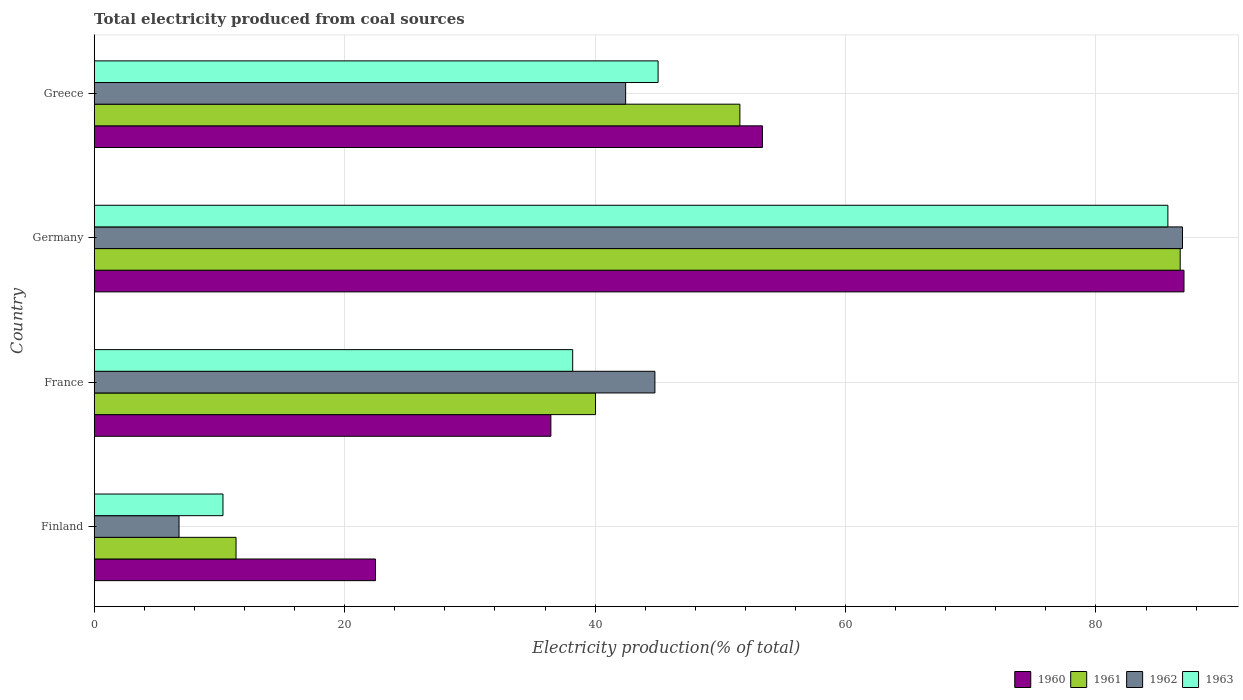How many groups of bars are there?
Make the answer very short. 4. Are the number of bars on each tick of the Y-axis equal?
Provide a succinct answer. Yes. How many bars are there on the 3rd tick from the bottom?
Provide a short and direct response. 4. In how many cases, is the number of bars for a given country not equal to the number of legend labels?
Your answer should be very brief. 0. What is the total electricity produced in 1960 in Finland?
Offer a terse response. 22.46. Across all countries, what is the maximum total electricity produced in 1963?
Your response must be concise. 85.74. Across all countries, what is the minimum total electricity produced in 1962?
Offer a terse response. 6.78. What is the total total electricity produced in 1961 in the graph?
Make the answer very short. 189.65. What is the difference between the total electricity produced in 1963 in Finland and that in Greece?
Keep it short and to the point. -34.75. What is the difference between the total electricity produced in 1962 in France and the total electricity produced in 1961 in Germany?
Make the answer very short. -41.95. What is the average total electricity produced in 1963 per country?
Offer a very short reply. 44.82. What is the difference between the total electricity produced in 1961 and total electricity produced in 1960 in Greece?
Your response must be concise. -1.8. What is the ratio of the total electricity produced in 1963 in Finland to that in France?
Ensure brevity in your answer.  0.27. Is the difference between the total electricity produced in 1961 in Germany and Greece greater than the difference between the total electricity produced in 1960 in Germany and Greece?
Your answer should be very brief. Yes. What is the difference between the highest and the second highest total electricity produced in 1961?
Your answer should be very brief. 35.16. What is the difference between the highest and the lowest total electricity produced in 1963?
Provide a short and direct response. 75.46. Is the sum of the total electricity produced in 1962 in Finland and France greater than the maximum total electricity produced in 1961 across all countries?
Offer a very short reply. No. Is it the case that in every country, the sum of the total electricity produced in 1962 and total electricity produced in 1963 is greater than the sum of total electricity produced in 1960 and total electricity produced in 1961?
Give a very brief answer. No. How many bars are there?
Your answer should be very brief. 16. What is the difference between two consecutive major ticks on the X-axis?
Give a very brief answer. 20. Are the values on the major ticks of X-axis written in scientific E-notation?
Give a very brief answer. No. Does the graph contain grids?
Offer a terse response. Yes. How are the legend labels stacked?
Offer a very short reply. Horizontal. What is the title of the graph?
Your response must be concise. Total electricity produced from coal sources. Does "1988" appear as one of the legend labels in the graph?
Provide a succinct answer. No. What is the Electricity production(% of total) in 1960 in Finland?
Provide a succinct answer. 22.46. What is the Electricity production(% of total) in 1961 in Finland?
Keep it short and to the point. 11.33. What is the Electricity production(% of total) of 1962 in Finland?
Offer a very short reply. 6.78. What is the Electricity production(% of total) in 1963 in Finland?
Your answer should be very brief. 10.28. What is the Electricity production(% of total) of 1960 in France?
Provide a short and direct response. 36.47. What is the Electricity production(% of total) in 1961 in France?
Your answer should be compact. 40.03. What is the Electricity production(% of total) in 1962 in France?
Give a very brief answer. 44.78. What is the Electricity production(% of total) of 1963 in France?
Provide a short and direct response. 38.21. What is the Electricity production(% of total) of 1960 in Germany?
Provide a short and direct response. 87.03. What is the Electricity production(% of total) in 1961 in Germany?
Keep it short and to the point. 86.73. What is the Electricity production(% of total) of 1962 in Germany?
Your answer should be very brief. 86.91. What is the Electricity production(% of total) of 1963 in Germany?
Provide a succinct answer. 85.74. What is the Electricity production(% of total) of 1960 in Greece?
Your answer should be compact. 53.36. What is the Electricity production(% of total) of 1961 in Greece?
Offer a very short reply. 51.56. What is the Electricity production(% of total) in 1962 in Greece?
Offer a very short reply. 42.44. What is the Electricity production(% of total) in 1963 in Greece?
Your answer should be very brief. 45.03. Across all countries, what is the maximum Electricity production(% of total) in 1960?
Offer a terse response. 87.03. Across all countries, what is the maximum Electricity production(% of total) in 1961?
Offer a very short reply. 86.73. Across all countries, what is the maximum Electricity production(% of total) in 1962?
Provide a short and direct response. 86.91. Across all countries, what is the maximum Electricity production(% of total) in 1963?
Your answer should be very brief. 85.74. Across all countries, what is the minimum Electricity production(% of total) of 1960?
Keep it short and to the point. 22.46. Across all countries, what is the minimum Electricity production(% of total) of 1961?
Offer a very short reply. 11.33. Across all countries, what is the minimum Electricity production(% of total) in 1962?
Your response must be concise. 6.78. Across all countries, what is the minimum Electricity production(% of total) in 1963?
Your response must be concise. 10.28. What is the total Electricity production(% of total) in 1960 in the graph?
Provide a short and direct response. 199.32. What is the total Electricity production(% of total) of 1961 in the graph?
Keep it short and to the point. 189.65. What is the total Electricity production(% of total) of 1962 in the graph?
Your answer should be very brief. 180.9. What is the total Electricity production(% of total) in 1963 in the graph?
Make the answer very short. 179.27. What is the difference between the Electricity production(% of total) of 1960 in Finland and that in France?
Offer a very short reply. -14.01. What is the difference between the Electricity production(% of total) in 1961 in Finland and that in France?
Make the answer very short. -28.71. What is the difference between the Electricity production(% of total) of 1962 in Finland and that in France?
Your answer should be compact. -38. What is the difference between the Electricity production(% of total) in 1963 in Finland and that in France?
Ensure brevity in your answer.  -27.93. What is the difference between the Electricity production(% of total) in 1960 in Finland and that in Germany?
Your answer should be compact. -64.57. What is the difference between the Electricity production(% of total) in 1961 in Finland and that in Germany?
Your response must be concise. -75.4. What is the difference between the Electricity production(% of total) in 1962 in Finland and that in Germany?
Ensure brevity in your answer.  -80.13. What is the difference between the Electricity production(% of total) in 1963 in Finland and that in Germany?
Ensure brevity in your answer.  -75.46. What is the difference between the Electricity production(% of total) of 1960 in Finland and that in Greece?
Your answer should be very brief. -30.9. What is the difference between the Electricity production(% of total) in 1961 in Finland and that in Greece?
Your response must be concise. -40.24. What is the difference between the Electricity production(% of total) in 1962 in Finland and that in Greece?
Your answer should be very brief. -35.66. What is the difference between the Electricity production(% of total) of 1963 in Finland and that in Greece?
Your answer should be very brief. -34.75. What is the difference between the Electricity production(% of total) in 1960 in France and that in Germany?
Keep it short and to the point. -50.56. What is the difference between the Electricity production(% of total) of 1961 in France and that in Germany?
Keep it short and to the point. -46.69. What is the difference between the Electricity production(% of total) in 1962 in France and that in Germany?
Your response must be concise. -42.13. What is the difference between the Electricity production(% of total) in 1963 in France and that in Germany?
Offer a terse response. -47.53. What is the difference between the Electricity production(% of total) in 1960 in France and that in Greece?
Keep it short and to the point. -16.89. What is the difference between the Electricity production(% of total) of 1961 in France and that in Greece?
Give a very brief answer. -11.53. What is the difference between the Electricity production(% of total) of 1962 in France and that in Greece?
Provide a short and direct response. 2.34. What is the difference between the Electricity production(% of total) of 1963 in France and that in Greece?
Ensure brevity in your answer.  -6.82. What is the difference between the Electricity production(% of total) in 1960 in Germany and that in Greece?
Your answer should be very brief. 33.67. What is the difference between the Electricity production(% of total) of 1961 in Germany and that in Greece?
Your response must be concise. 35.16. What is the difference between the Electricity production(% of total) in 1962 in Germany and that in Greece?
Ensure brevity in your answer.  44.47. What is the difference between the Electricity production(% of total) in 1963 in Germany and that in Greece?
Offer a terse response. 40.71. What is the difference between the Electricity production(% of total) of 1960 in Finland and the Electricity production(% of total) of 1961 in France?
Your answer should be very brief. -17.57. What is the difference between the Electricity production(% of total) in 1960 in Finland and the Electricity production(% of total) in 1962 in France?
Provide a short and direct response. -22.31. What is the difference between the Electricity production(% of total) of 1960 in Finland and the Electricity production(% of total) of 1963 in France?
Ensure brevity in your answer.  -15.75. What is the difference between the Electricity production(% of total) in 1961 in Finland and the Electricity production(% of total) in 1962 in France?
Offer a very short reply. -33.45. What is the difference between the Electricity production(% of total) in 1961 in Finland and the Electricity production(% of total) in 1963 in France?
Provide a short and direct response. -26.88. What is the difference between the Electricity production(% of total) of 1962 in Finland and the Electricity production(% of total) of 1963 in France?
Keep it short and to the point. -31.44. What is the difference between the Electricity production(% of total) of 1960 in Finland and the Electricity production(% of total) of 1961 in Germany?
Your answer should be very brief. -64.26. What is the difference between the Electricity production(% of total) of 1960 in Finland and the Electricity production(% of total) of 1962 in Germany?
Your answer should be compact. -64.45. What is the difference between the Electricity production(% of total) of 1960 in Finland and the Electricity production(% of total) of 1963 in Germany?
Give a very brief answer. -63.28. What is the difference between the Electricity production(% of total) in 1961 in Finland and the Electricity production(% of total) in 1962 in Germany?
Your answer should be very brief. -75.58. What is the difference between the Electricity production(% of total) in 1961 in Finland and the Electricity production(% of total) in 1963 in Germany?
Your answer should be compact. -74.41. What is the difference between the Electricity production(% of total) of 1962 in Finland and the Electricity production(% of total) of 1963 in Germany?
Provide a short and direct response. -78.97. What is the difference between the Electricity production(% of total) in 1960 in Finland and the Electricity production(% of total) in 1961 in Greece?
Provide a short and direct response. -29.1. What is the difference between the Electricity production(% of total) in 1960 in Finland and the Electricity production(% of total) in 1962 in Greece?
Provide a short and direct response. -19.98. What is the difference between the Electricity production(% of total) of 1960 in Finland and the Electricity production(% of total) of 1963 in Greece?
Offer a terse response. -22.57. What is the difference between the Electricity production(% of total) in 1961 in Finland and the Electricity production(% of total) in 1962 in Greece?
Offer a terse response. -31.11. What is the difference between the Electricity production(% of total) of 1961 in Finland and the Electricity production(% of total) of 1963 in Greece?
Keep it short and to the point. -33.7. What is the difference between the Electricity production(% of total) of 1962 in Finland and the Electricity production(% of total) of 1963 in Greece?
Ensure brevity in your answer.  -38.26. What is the difference between the Electricity production(% of total) of 1960 in France and the Electricity production(% of total) of 1961 in Germany?
Your response must be concise. -50.26. What is the difference between the Electricity production(% of total) in 1960 in France and the Electricity production(% of total) in 1962 in Germany?
Give a very brief answer. -50.44. What is the difference between the Electricity production(% of total) in 1960 in France and the Electricity production(% of total) in 1963 in Germany?
Your answer should be compact. -49.27. What is the difference between the Electricity production(% of total) in 1961 in France and the Electricity production(% of total) in 1962 in Germany?
Ensure brevity in your answer.  -46.87. What is the difference between the Electricity production(% of total) in 1961 in France and the Electricity production(% of total) in 1963 in Germany?
Offer a very short reply. -45.71. What is the difference between the Electricity production(% of total) in 1962 in France and the Electricity production(% of total) in 1963 in Germany?
Your answer should be compact. -40.97. What is the difference between the Electricity production(% of total) of 1960 in France and the Electricity production(% of total) of 1961 in Greece?
Offer a terse response. -15.09. What is the difference between the Electricity production(% of total) of 1960 in France and the Electricity production(% of total) of 1962 in Greece?
Provide a short and direct response. -5.97. What is the difference between the Electricity production(% of total) of 1960 in France and the Electricity production(% of total) of 1963 in Greece?
Provide a short and direct response. -8.56. What is the difference between the Electricity production(% of total) of 1961 in France and the Electricity production(% of total) of 1962 in Greece?
Your answer should be very brief. -2.41. What is the difference between the Electricity production(% of total) in 1961 in France and the Electricity production(% of total) in 1963 in Greece?
Ensure brevity in your answer.  -5. What is the difference between the Electricity production(% of total) in 1962 in France and the Electricity production(% of total) in 1963 in Greece?
Offer a very short reply. -0.25. What is the difference between the Electricity production(% of total) of 1960 in Germany and the Electricity production(% of total) of 1961 in Greece?
Provide a succinct answer. 35.47. What is the difference between the Electricity production(% of total) in 1960 in Germany and the Electricity production(% of total) in 1962 in Greece?
Give a very brief answer. 44.59. What is the difference between the Electricity production(% of total) in 1960 in Germany and the Electricity production(% of total) in 1963 in Greece?
Ensure brevity in your answer.  42. What is the difference between the Electricity production(% of total) of 1961 in Germany and the Electricity production(% of total) of 1962 in Greece?
Offer a terse response. 44.29. What is the difference between the Electricity production(% of total) in 1961 in Germany and the Electricity production(% of total) in 1963 in Greece?
Offer a very short reply. 41.69. What is the difference between the Electricity production(% of total) in 1962 in Germany and the Electricity production(% of total) in 1963 in Greece?
Your answer should be compact. 41.88. What is the average Electricity production(% of total) in 1960 per country?
Give a very brief answer. 49.83. What is the average Electricity production(% of total) of 1961 per country?
Your response must be concise. 47.41. What is the average Electricity production(% of total) in 1962 per country?
Your response must be concise. 45.23. What is the average Electricity production(% of total) in 1963 per country?
Your answer should be compact. 44.82. What is the difference between the Electricity production(% of total) of 1960 and Electricity production(% of total) of 1961 in Finland?
Your answer should be compact. 11.14. What is the difference between the Electricity production(% of total) in 1960 and Electricity production(% of total) in 1962 in Finland?
Offer a terse response. 15.69. What is the difference between the Electricity production(% of total) of 1960 and Electricity production(% of total) of 1963 in Finland?
Keep it short and to the point. 12.18. What is the difference between the Electricity production(% of total) of 1961 and Electricity production(% of total) of 1962 in Finland?
Keep it short and to the point. 4.55. What is the difference between the Electricity production(% of total) in 1961 and Electricity production(% of total) in 1963 in Finland?
Offer a very short reply. 1.04. What is the difference between the Electricity production(% of total) in 1962 and Electricity production(% of total) in 1963 in Finland?
Keep it short and to the point. -3.51. What is the difference between the Electricity production(% of total) in 1960 and Electricity production(% of total) in 1961 in France?
Your response must be concise. -3.57. What is the difference between the Electricity production(% of total) of 1960 and Electricity production(% of total) of 1962 in France?
Keep it short and to the point. -8.31. What is the difference between the Electricity production(% of total) in 1960 and Electricity production(% of total) in 1963 in France?
Keep it short and to the point. -1.74. What is the difference between the Electricity production(% of total) of 1961 and Electricity production(% of total) of 1962 in France?
Make the answer very short. -4.74. What is the difference between the Electricity production(% of total) in 1961 and Electricity production(% of total) in 1963 in France?
Keep it short and to the point. 1.82. What is the difference between the Electricity production(% of total) of 1962 and Electricity production(% of total) of 1963 in France?
Your answer should be very brief. 6.57. What is the difference between the Electricity production(% of total) in 1960 and Electricity production(% of total) in 1961 in Germany?
Offer a very short reply. 0.3. What is the difference between the Electricity production(% of total) of 1960 and Electricity production(% of total) of 1962 in Germany?
Keep it short and to the point. 0.12. What is the difference between the Electricity production(% of total) of 1960 and Electricity production(% of total) of 1963 in Germany?
Make the answer very short. 1.29. What is the difference between the Electricity production(% of total) in 1961 and Electricity production(% of total) in 1962 in Germany?
Offer a very short reply. -0.18. What is the difference between the Electricity production(% of total) of 1961 and Electricity production(% of total) of 1963 in Germany?
Your answer should be compact. 0.98. What is the difference between the Electricity production(% of total) in 1960 and Electricity production(% of total) in 1961 in Greece?
Your answer should be compact. 1.8. What is the difference between the Electricity production(% of total) of 1960 and Electricity production(% of total) of 1962 in Greece?
Keep it short and to the point. 10.92. What is the difference between the Electricity production(% of total) in 1960 and Electricity production(% of total) in 1963 in Greece?
Make the answer very short. 8.33. What is the difference between the Electricity production(% of total) of 1961 and Electricity production(% of total) of 1962 in Greece?
Make the answer very short. 9.12. What is the difference between the Electricity production(% of total) in 1961 and Electricity production(% of total) in 1963 in Greece?
Ensure brevity in your answer.  6.53. What is the difference between the Electricity production(% of total) of 1962 and Electricity production(% of total) of 1963 in Greece?
Keep it short and to the point. -2.59. What is the ratio of the Electricity production(% of total) in 1960 in Finland to that in France?
Your answer should be compact. 0.62. What is the ratio of the Electricity production(% of total) of 1961 in Finland to that in France?
Ensure brevity in your answer.  0.28. What is the ratio of the Electricity production(% of total) of 1962 in Finland to that in France?
Provide a succinct answer. 0.15. What is the ratio of the Electricity production(% of total) in 1963 in Finland to that in France?
Your answer should be compact. 0.27. What is the ratio of the Electricity production(% of total) in 1960 in Finland to that in Germany?
Your answer should be very brief. 0.26. What is the ratio of the Electricity production(% of total) of 1961 in Finland to that in Germany?
Your answer should be very brief. 0.13. What is the ratio of the Electricity production(% of total) in 1962 in Finland to that in Germany?
Your answer should be very brief. 0.08. What is the ratio of the Electricity production(% of total) in 1963 in Finland to that in Germany?
Your response must be concise. 0.12. What is the ratio of the Electricity production(% of total) of 1960 in Finland to that in Greece?
Offer a terse response. 0.42. What is the ratio of the Electricity production(% of total) of 1961 in Finland to that in Greece?
Ensure brevity in your answer.  0.22. What is the ratio of the Electricity production(% of total) in 1962 in Finland to that in Greece?
Provide a succinct answer. 0.16. What is the ratio of the Electricity production(% of total) of 1963 in Finland to that in Greece?
Offer a very short reply. 0.23. What is the ratio of the Electricity production(% of total) of 1960 in France to that in Germany?
Provide a short and direct response. 0.42. What is the ratio of the Electricity production(% of total) of 1961 in France to that in Germany?
Offer a terse response. 0.46. What is the ratio of the Electricity production(% of total) of 1962 in France to that in Germany?
Provide a short and direct response. 0.52. What is the ratio of the Electricity production(% of total) of 1963 in France to that in Germany?
Offer a very short reply. 0.45. What is the ratio of the Electricity production(% of total) in 1960 in France to that in Greece?
Provide a short and direct response. 0.68. What is the ratio of the Electricity production(% of total) of 1961 in France to that in Greece?
Make the answer very short. 0.78. What is the ratio of the Electricity production(% of total) in 1962 in France to that in Greece?
Keep it short and to the point. 1.06. What is the ratio of the Electricity production(% of total) of 1963 in France to that in Greece?
Provide a succinct answer. 0.85. What is the ratio of the Electricity production(% of total) in 1960 in Germany to that in Greece?
Keep it short and to the point. 1.63. What is the ratio of the Electricity production(% of total) in 1961 in Germany to that in Greece?
Your response must be concise. 1.68. What is the ratio of the Electricity production(% of total) in 1962 in Germany to that in Greece?
Make the answer very short. 2.05. What is the ratio of the Electricity production(% of total) in 1963 in Germany to that in Greece?
Offer a terse response. 1.9. What is the difference between the highest and the second highest Electricity production(% of total) in 1960?
Offer a very short reply. 33.67. What is the difference between the highest and the second highest Electricity production(% of total) in 1961?
Provide a short and direct response. 35.16. What is the difference between the highest and the second highest Electricity production(% of total) of 1962?
Keep it short and to the point. 42.13. What is the difference between the highest and the second highest Electricity production(% of total) in 1963?
Provide a short and direct response. 40.71. What is the difference between the highest and the lowest Electricity production(% of total) in 1960?
Your answer should be compact. 64.57. What is the difference between the highest and the lowest Electricity production(% of total) in 1961?
Keep it short and to the point. 75.4. What is the difference between the highest and the lowest Electricity production(% of total) in 1962?
Your response must be concise. 80.13. What is the difference between the highest and the lowest Electricity production(% of total) of 1963?
Offer a very short reply. 75.46. 